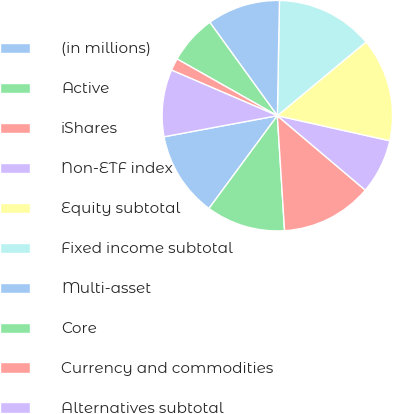<chart> <loc_0><loc_0><loc_500><loc_500><pie_chart><fcel>(in millions)<fcel>Active<fcel>iShares<fcel>Non-ETF index<fcel>Equity subtotal<fcel>Fixed income subtotal<fcel>Multi-asset<fcel>Core<fcel>Currency and commodities<fcel>Alternatives subtotal<nl><fcel>11.96%<fcel>11.11%<fcel>12.82%<fcel>7.69%<fcel>14.53%<fcel>13.67%<fcel>10.26%<fcel>6.84%<fcel>1.72%<fcel>9.4%<nl></chart> 